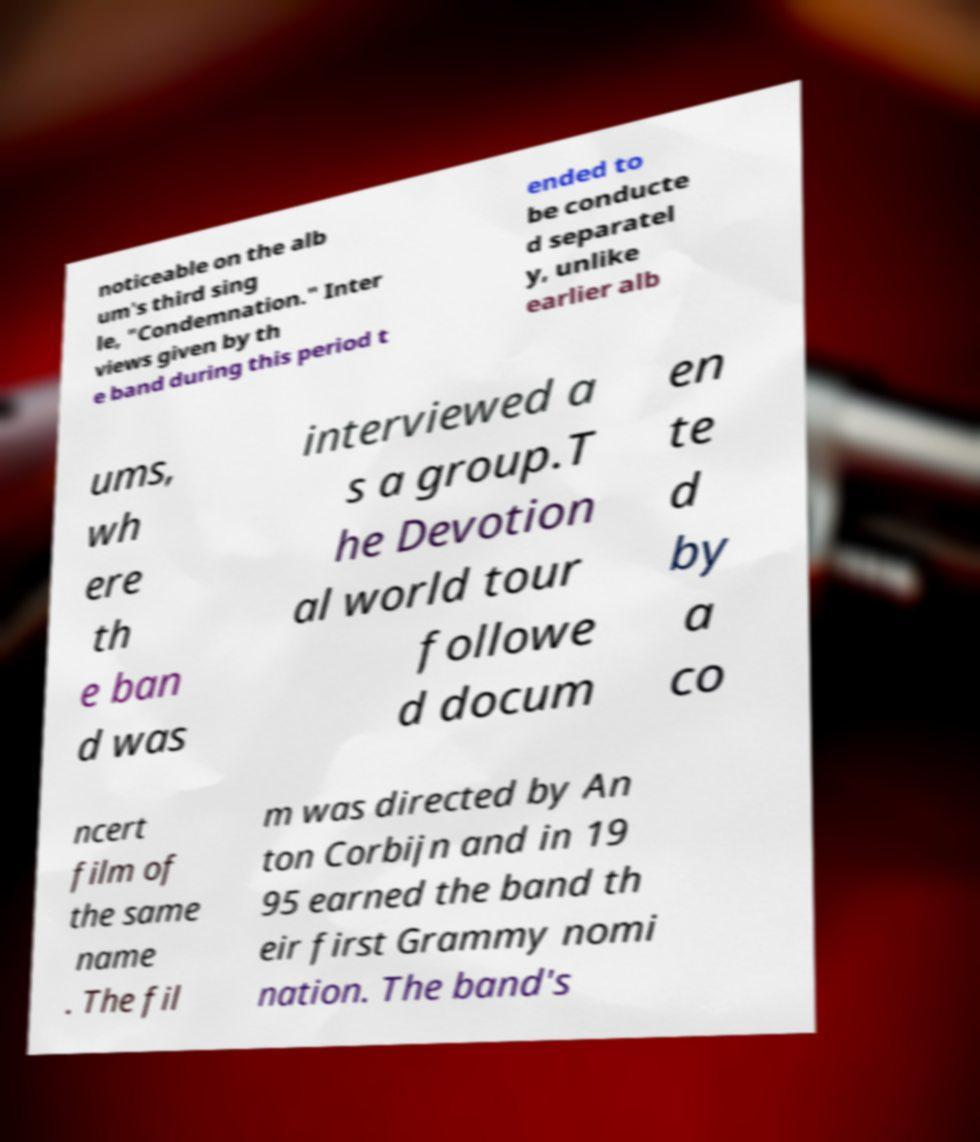Please identify and transcribe the text found in this image. noticeable on the alb um's third sing le, "Condemnation." Inter views given by th e band during this period t ended to be conducte d separatel y, unlike earlier alb ums, wh ere th e ban d was interviewed a s a group.T he Devotion al world tour followe d docum en te d by a co ncert film of the same name . The fil m was directed by An ton Corbijn and in 19 95 earned the band th eir first Grammy nomi nation. The band's 